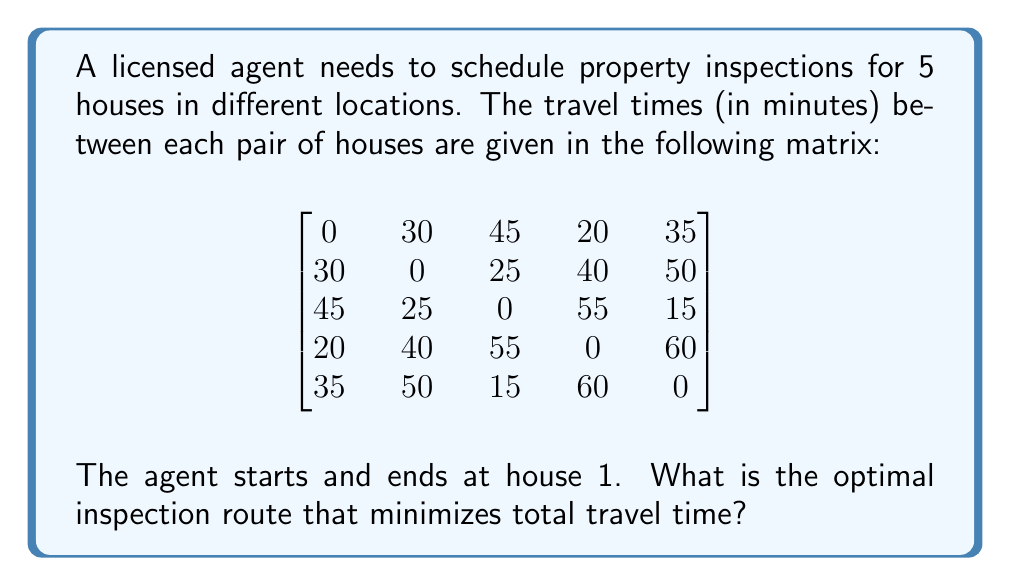Can you answer this question? To solve this problem, we can use the Traveling Salesman Problem (TSP) approach. Since the number of houses is small, we can use a brute-force method to find the optimal route.

Step 1: List all possible routes starting and ending at house 1.
There are (5-1)! = 24 possible routes.

Step 2: Calculate the total travel time for each route.
For example, let's calculate the time for route 1-2-3-4-5-1:
Time = 30 + 25 + 55 + 60 + 35 = 205 minutes

Step 3: Compare all routes and find the one with the minimum total time.
After calculating all routes, we find that the optimal route is:

1 → 4 → 2 → 3 → 5 → 1

Step 4: Calculate the total travel time for the optimal route:
Time = 20 + 40 + 25 + 15 + 35 = 135 minutes

This route minimizes the total travel time and allows the agent to efficiently schedule the property inspections.
Answer: Optimal route: 1 → 4 → 2 → 3 → 5 → 1; Total time: 135 minutes 